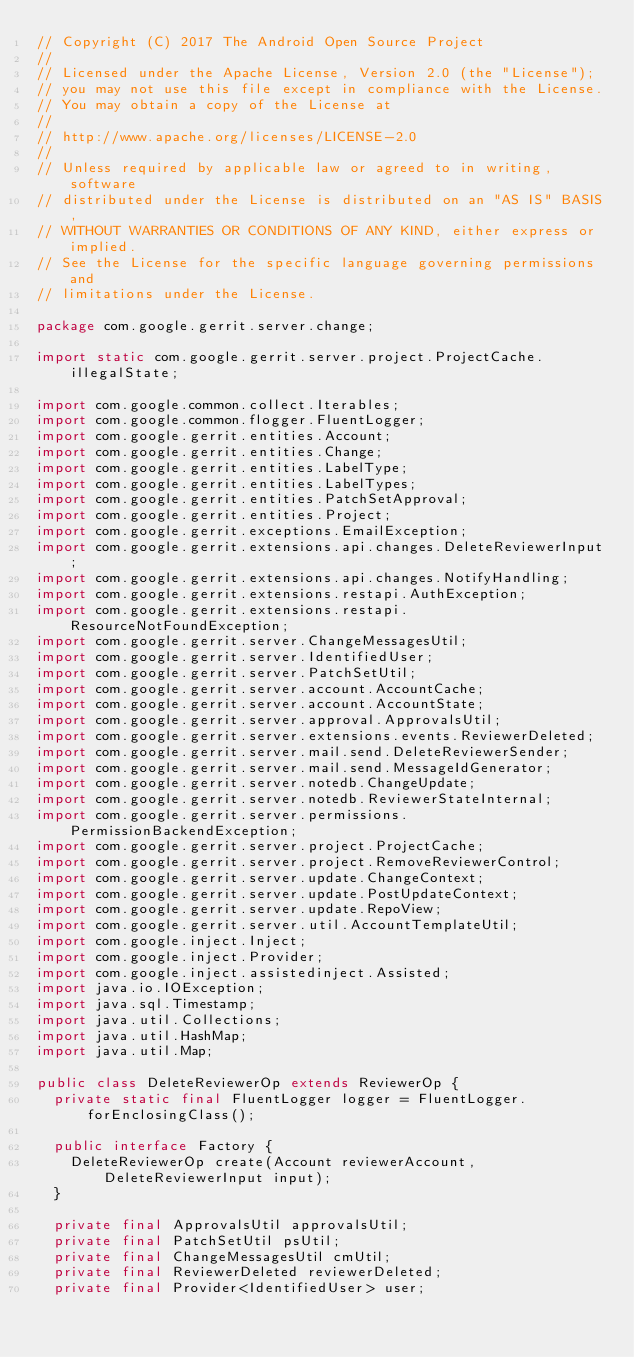<code> <loc_0><loc_0><loc_500><loc_500><_Java_>// Copyright (C) 2017 The Android Open Source Project
//
// Licensed under the Apache License, Version 2.0 (the "License");
// you may not use this file except in compliance with the License.
// You may obtain a copy of the License at
//
// http://www.apache.org/licenses/LICENSE-2.0
//
// Unless required by applicable law or agreed to in writing, software
// distributed under the License is distributed on an "AS IS" BASIS,
// WITHOUT WARRANTIES OR CONDITIONS OF ANY KIND, either express or implied.
// See the License for the specific language governing permissions and
// limitations under the License.

package com.google.gerrit.server.change;

import static com.google.gerrit.server.project.ProjectCache.illegalState;

import com.google.common.collect.Iterables;
import com.google.common.flogger.FluentLogger;
import com.google.gerrit.entities.Account;
import com.google.gerrit.entities.Change;
import com.google.gerrit.entities.LabelType;
import com.google.gerrit.entities.LabelTypes;
import com.google.gerrit.entities.PatchSetApproval;
import com.google.gerrit.entities.Project;
import com.google.gerrit.exceptions.EmailException;
import com.google.gerrit.extensions.api.changes.DeleteReviewerInput;
import com.google.gerrit.extensions.api.changes.NotifyHandling;
import com.google.gerrit.extensions.restapi.AuthException;
import com.google.gerrit.extensions.restapi.ResourceNotFoundException;
import com.google.gerrit.server.ChangeMessagesUtil;
import com.google.gerrit.server.IdentifiedUser;
import com.google.gerrit.server.PatchSetUtil;
import com.google.gerrit.server.account.AccountCache;
import com.google.gerrit.server.account.AccountState;
import com.google.gerrit.server.approval.ApprovalsUtil;
import com.google.gerrit.server.extensions.events.ReviewerDeleted;
import com.google.gerrit.server.mail.send.DeleteReviewerSender;
import com.google.gerrit.server.mail.send.MessageIdGenerator;
import com.google.gerrit.server.notedb.ChangeUpdate;
import com.google.gerrit.server.notedb.ReviewerStateInternal;
import com.google.gerrit.server.permissions.PermissionBackendException;
import com.google.gerrit.server.project.ProjectCache;
import com.google.gerrit.server.project.RemoveReviewerControl;
import com.google.gerrit.server.update.ChangeContext;
import com.google.gerrit.server.update.PostUpdateContext;
import com.google.gerrit.server.update.RepoView;
import com.google.gerrit.server.util.AccountTemplateUtil;
import com.google.inject.Inject;
import com.google.inject.Provider;
import com.google.inject.assistedinject.Assisted;
import java.io.IOException;
import java.sql.Timestamp;
import java.util.Collections;
import java.util.HashMap;
import java.util.Map;

public class DeleteReviewerOp extends ReviewerOp {
  private static final FluentLogger logger = FluentLogger.forEnclosingClass();

  public interface Factory {
    DeleteReviewerOp create(Account reviewerAccount, DeleteReviewerInput input);
  }

  private final ApprovalsUtil approvalsUtil;
  private final PatchSetUtil psUtil;
  private final ChangeMessagesUtil cmUtil;
  private final ReviewerDeleted reviewerDeleted;
  private final Provider<IdentifiedUser> user;</code> 